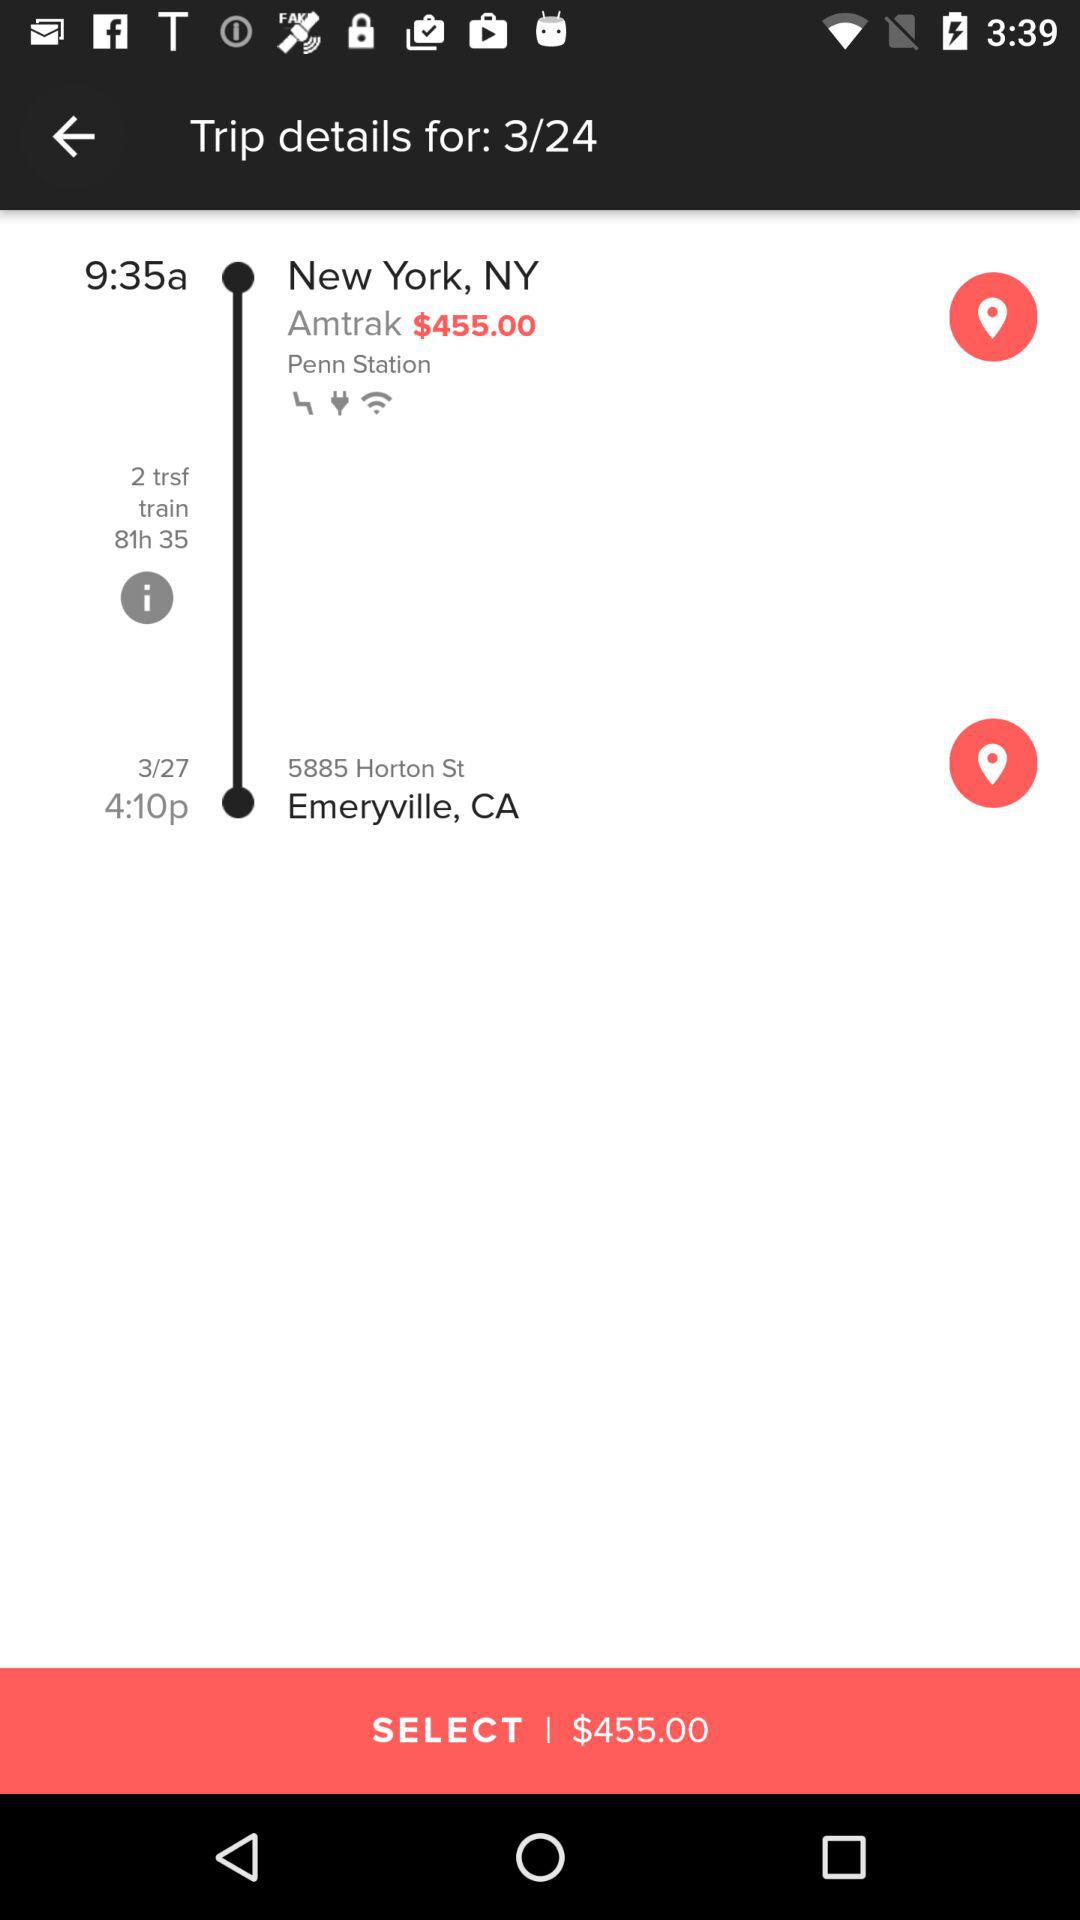What trip detail am I on? You are on the 3rd trip detail. 